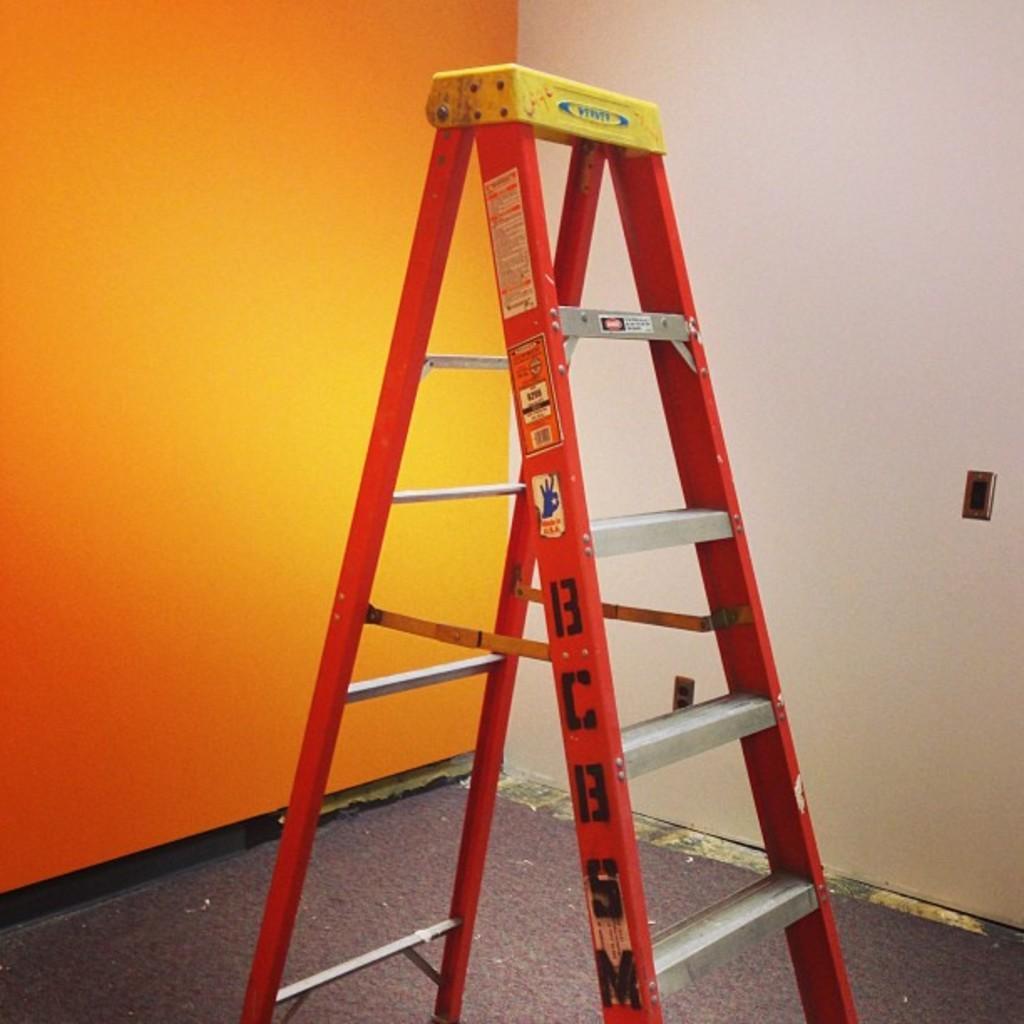Could you give a brief overview of what you see in this image? This picture is taken inside the room. In this image, in the middle, we can see a ladder. On the right side, we can see a white color wall. On the left side, we can also see an orange color wall. At the bottom, we can see a floor. 